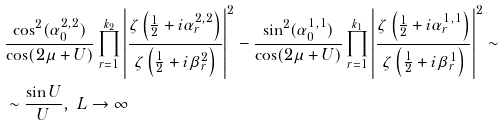<formula> <loc_0><loc_0><loc_500><loc_500>& \frac { \cos ^ { 2 } ( \alpha _ { 0 } ^ { 2 , 2 } ) } { \cos ( 2 \mu + U ) } \prod _ { r = 1 } ^ { k _ { 2 } } \left | \frac { \zeta \left ( \frac { 1 } { 2 } + i \alpha _ { r } ^ { 2 , 2 } \right ) } { \zeta \left ( \frac { 1 } { 2 } + i \beta _ { r } ^ { 2 } \right ) } \right | ^ { 2 } - \frac { \sin ^ { 2 } ( \alpha _ { 0 } ^ { 1 , 1 } ) } { \cos ( 2 \mu + U ) } \prod _ { r = 1 } ^ { k _ { 1 } } \left | \frac { \zeta \left ( \frac { 1 } { 2 } + i \alpha _ { r } ^ { 1 , 1 } \right ) } { \zeta \left ( \frac { 1 } { 2 } + i \beta _ { r } ^ { 1 } \right ) } \right | ^ { 2 } \sim \\ & \sim \frac { \sin U } { U } , \ L \to \infty</formula> 